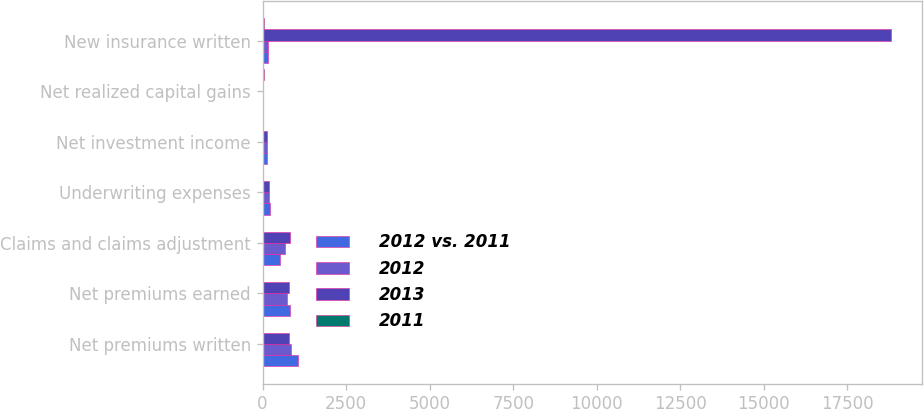Convert chart. <chart><loc_0><loc_0><loc_500><loc_500><stacked_bar_chart><ecel><fcel>Net premiums written<fcel>Net premiums earned<fcel>Claims and claims adjustment<fcel>Underwriting expenses<fcel>Net investment income<fcel>Net realized capital gains<fcel>New insurance written<nl><fcel>2012 vs. 2011<fcel>1048<fcel>809<fcel>514<fcel>222<fcel>132<fcel>8<fcel>166.5<nl><fcel>2012<fcel>858<fcel>715<fcel>659<fcel>193<fcel>146<fcel>6<fcel>166.5<nl><fcel>2013<fcel>801<fcel>792<fcel>834<fcel>187<fcel>132<fcel>20<fcel>18792<nl><fcel>2011<fcel>22<fcel>13<fcel>22<fcel>15<fcel>10<fcel>33<fcel>33<nl></chart> 